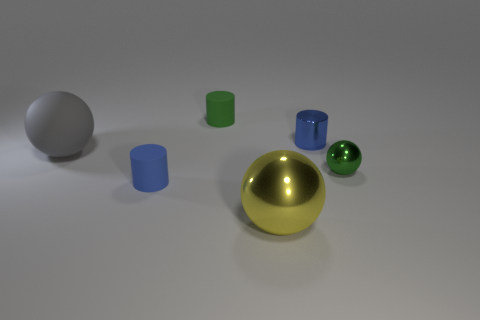Add 3 metal cylinders. How many objects exist? 9 Add 1 green objects. How many green objects exist? 3 Subtract 0 purple spheres. How many objects are left? 6 Subtract all purple shiny balls. Subtract all small blue cylinders. How many objects are left? 4 Add 3 green metallic balls. How many green metallic balls are left? 4 